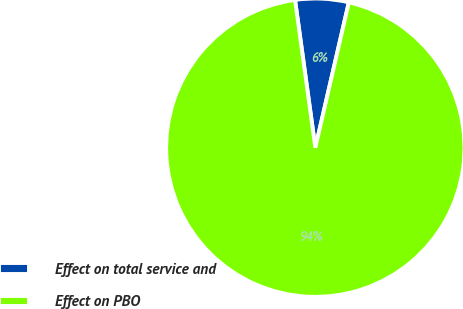<chart> <loc_0><loc_0><loc_500><loc_500><pie_chart><fcel>Effect on total service and<fcel>Effect on PBO<nl><fcel>5.78%<fcel>94.22%<nl></chart> 